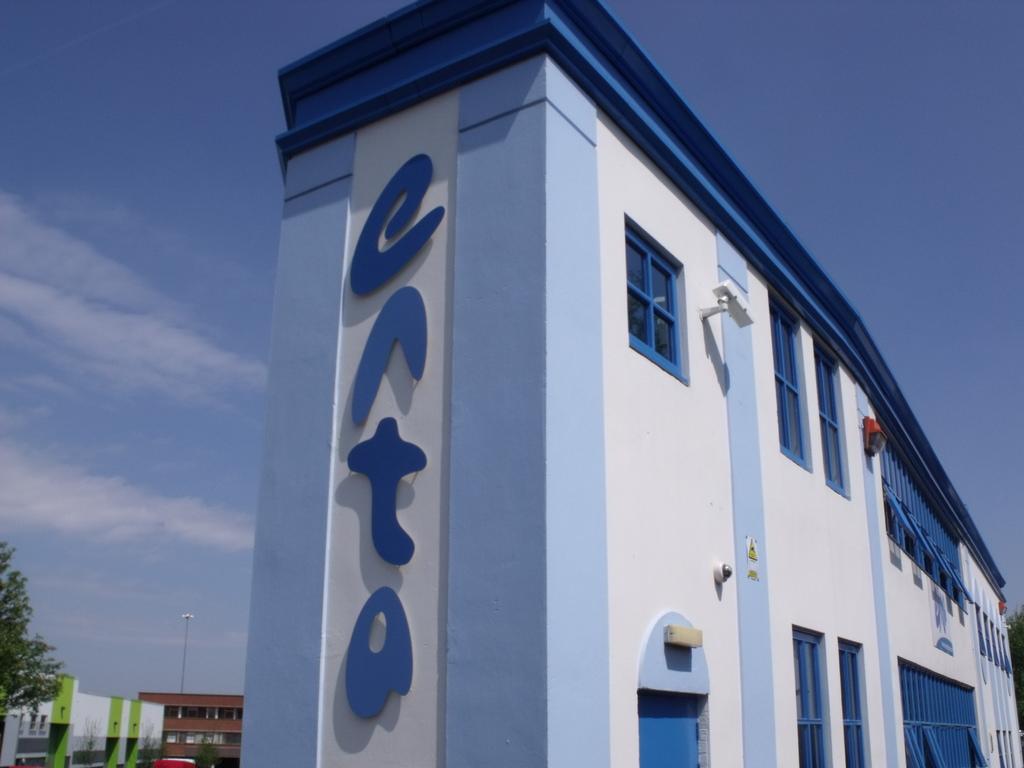In one or two sentences, can you explain what this image depicts? In this picture we can see building. On the building we can see windows, doors and camera. In the bottom left corner we can see another building, street lights and tree. On the left we can see sky and clouds. 